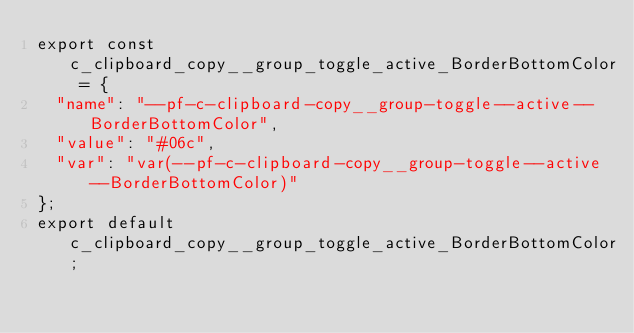<code> <loc_0><loc_0><loc_500><loc_500><_JavaScript_>export const c_clipboard_copy__group_toggle_active_BorderBottomColor = {
  "name": "--pf-c-clipboard-copy__group-toggle--active--BorderBottomColor",
  "value": "#06c",
  "var": "var(--pf-c-clipboard-copy__group-toggle--active--BorderBottomColor)"
};
export default c_clipboard_copy__group_toggle_active_BorderBottomColor;</code> 